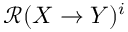Convert formula to latex. <formula><loc_0><loc_0><loc_500><loc_500>\mathcal { R } ( X \rightarrow Y ) ^ { i }</formula> 